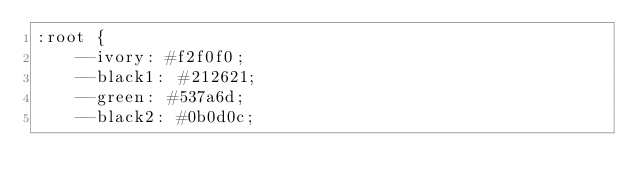<code> <loc_0><loc_0><loc_500><loc_500><_CSS_>:root {
    --ivory: #f2f0f0;
    --black1: #212621;
    --green: #537a6d;
    --black2: #0b0d0c;</code> 